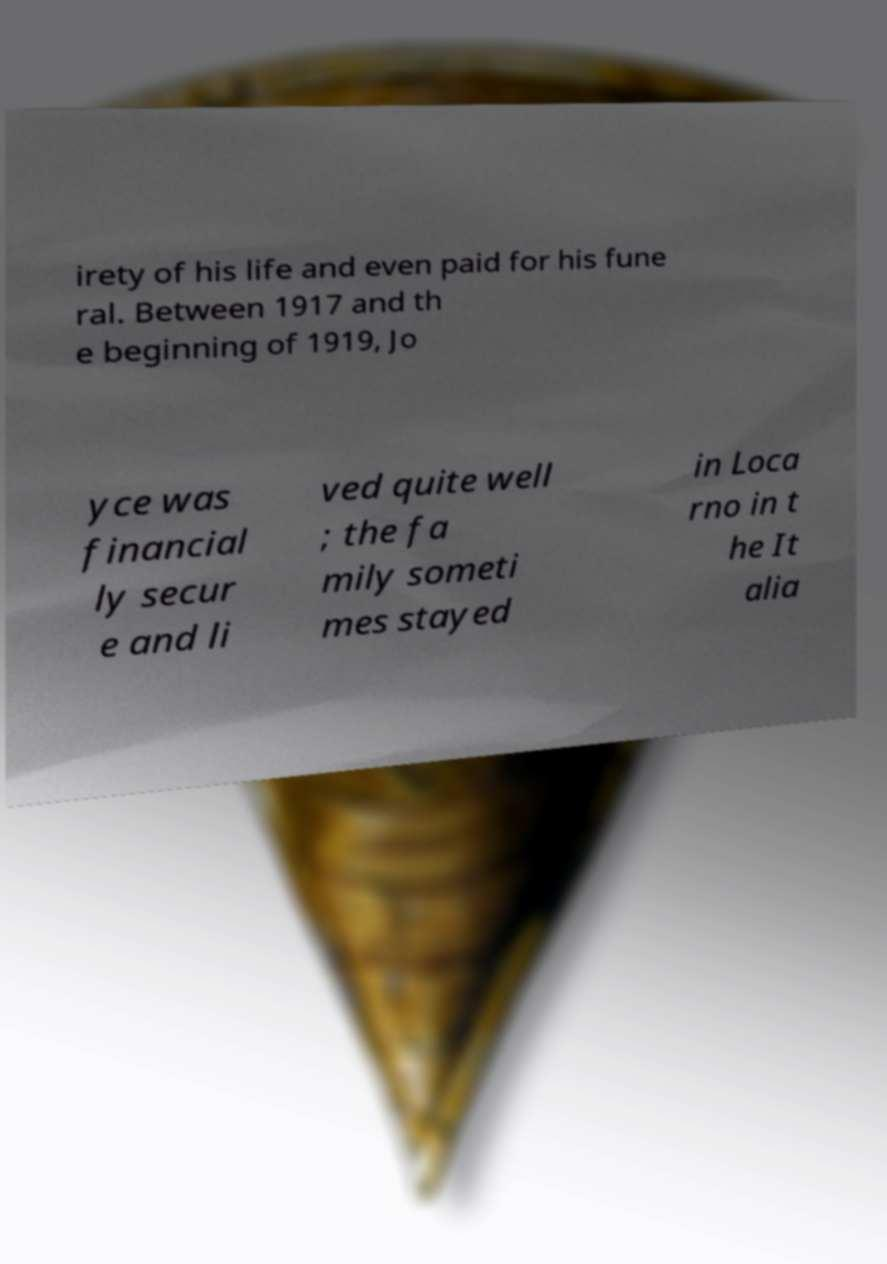What messages or text are displayed in this image? I need them in a readable, typed format. irety of his life and even paid for his fune ral. Between 1917 and th e beginning of 1919, Jo yce was financial ly secur e and li ved quite well ; the fa mily someti mes stayed in Loca rno in t he It alia 